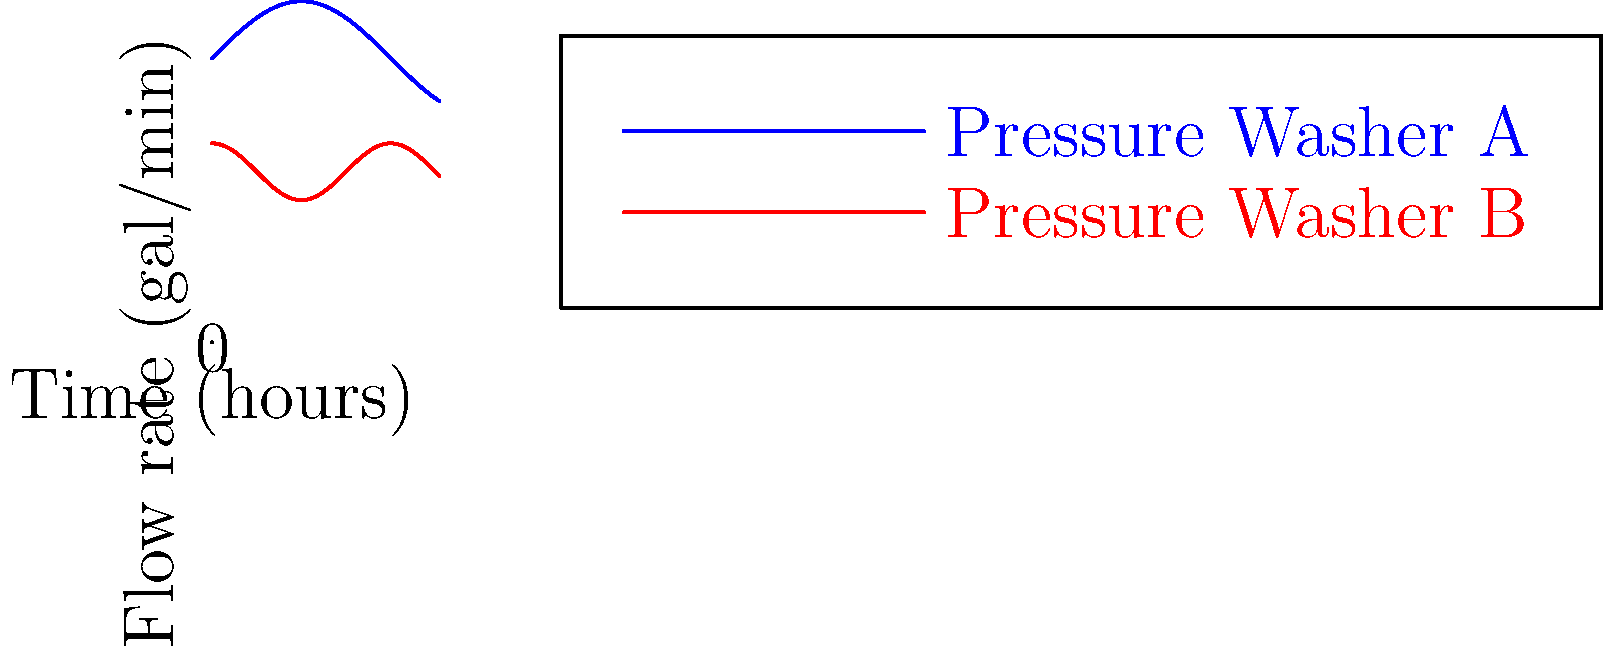As a nurse who runs a part-time pressure washing business, you're analyzing water consumption data. The graph shows the flow rates of two pressure washers over 4 hours. Pressure Washer A's flow rate (in gallons per minute) is given by $f(t) = 5 + \sin(t)$, while Pressure Washer B's is given by $g(t) = 3 + 0.5\cos(2t)$, where $t$ is time in hours. Calculate the difference in total water consumption between the two pressure washers over the 4-hour period. To solve this problem, we need to calculate the total water consumption for each pressure washer and then find the difference. The total water consumption is given by the integral of the flow rate function over the 4-hour period.

1. For Pressure Washer A:
   $$\int_0^4 (5 + \sin(t)) dt = [5t - \cos(t)]_0^4 = 20 - \cos(4) + \cos(0) = 20 - \cos(4) + 1$$

2. For Pressure Washer B:
   $$\int_0^4 (3 + 0.5\cos(2t)) dt = [3t + 0.25\sin(2t)]_0^4 = 12 + 0.25\sin(8) - 0.25\sin(0) = 12 + 0.25\sin(8)$$

3. Convert the results from step 1 and 2 from hours to minutes:
   Washer A: $(20 - \cos(4) + 1) \times 60 = 1260.46$ gallons
   Washer B: $(12 + 0.25\sin(8)) \times 60 = 720.49$ gallons

4. Calculate the difference:
   $1260.46 - 720.49 = 539.97$ gallons

Therefore, the difference in total water consumption between the two pressure washers over the 4-hour period is approximately 539.97 gallons.
Answer: 539.97 gallons 